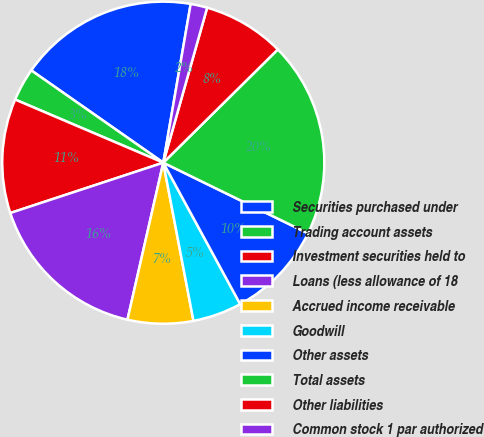<chart> <loc_0><loc_0><loc_500><loc_500><pie_chart><fcel>Securities purchased under<fcel>Trading account assets<fcel>Investment securities held to<fcel>Loans (less allowance of 18<fcel>Accrued income receivable<fcel>Goodwill<fcel>Other assets<fcel>Total assets<fcel>Other liabilities<fcel>Common stock 1 par authorized<nl><fcel>18.01%<fcel>3.3%<fcel>11.47%<fcel>16.37%<fcel>6.57%<fcel>4.93%<fcel>9.84%<fcel>19.64%<fcel>8.2%<fcel>1.67%<nl></chart> 